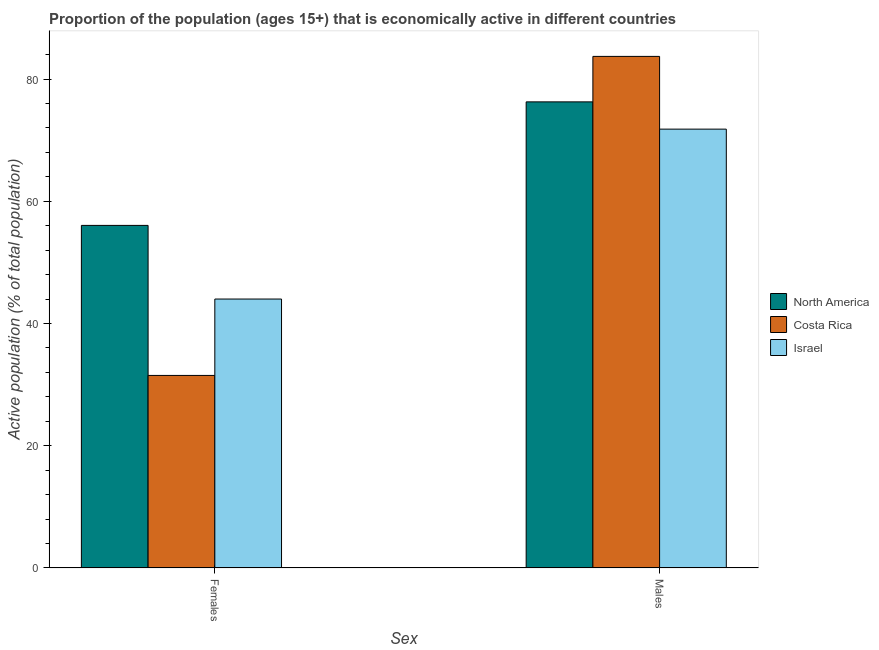How many different coloured bars are there?
Give a very brief answer. 3. Are the number of bars per tick equal to the number of legend labels?
Provide a short and direct response. Yes. How many bars are there on the 2nd tick from the left?
Keep it short and to the point. 3. How many bars are there on the 1st tick from the right?
Provide a succinct answer. 3. What is the label of the 1st group of bars from the left?
Your response must be concise. Females. What is the percentage of economically active female population in North America?
Provide a succinct answer. 56.05. Across all countries, what is the maximum percentage of economically active female population?
Your answer should be compact. 56.05. Across all countries, what is the minimum percentage of economically active female population?
Offer a terse response. 31.5. In which country was the percentage of economically active male population maximum?
Ensure brevity in your answer.  Costa Rica. In which country was the percentage of economically active male population minimum?
Provide a succinct answer. Israel. What is the total percentage of economically active female population in the graph?
Give a very brief answer. 131.55. What is the difference between the percentage of economically active male population in Israel and that in North America?
Offer a terse response. -4.46. What is the difference between the percentage of economically active female population in Costa Rica and the percentage of economically active male population in Israel?
Keep it short and to the point. -40.3. What is the average percentage of economically active male population per country?
Ensure brevity in your answer.  77.25. What is the difference between the percentage of economically active female population and percentage of economically active male population in North America?
Give a very brief answer. -20.21. In how many countries, is the percentage of economically active female population greater than 36 %?
Ensure brevity in your answer.  2. What is the ratio of the percentage of economically active female population in Israel to that in North America?
Provide a short and direct response. 0.79. In how many countries, is the percentage of economically active male population greater than the average percentage of economically active male population taken over all countries?
Provide a succinct answer. 1. What does the 1st bar from the left in Males represents?
Your response must be concise. North America. What does the 2nd bar from the right in Females represents?
Your response must be concise. Costa Rica. How many countries are there in the graph?
Keep it short and to the point. 3. Are the values on the major ticks of Y-axis written in scientific E-notation?
Make the answer very short. No. Does the graph contain any zero values?
Your response must be concise. No. How are the legend labels stacked?
Your response must be concise. Vertical. What is the title of the graph?
Offer a terse response. Proportion of the population (ages 15+) that is economically active in different countries. Does "Somalia" appear as one of the legend labels in the graph?
Provide a short and direct response. No. What is the label or title of the X-axis?
Give a very brief answer. Sex. What is the label or title of the Y-axis?
Offer a very short reply. Active population (% of total population). What is the Active population (% of total population) in North America in Females?
Provide a short and direct response. 56.05. What is the Active population (% of total population) in Costa Rica in Females?
Keep it short and to the point. 31.5. What is the Active population (% of total population) of Israel in Females?
Your response must be concise. 44. What is the Active population (% of total population) in North America in Males?
Your answer should be very brief. 76.26. What is the Active population (% of total population) of Costa Rica in Males?
Offer a terse response. 83.7. What is the Active population (% of total population) of Israel in Males?
Offer a terse response. 71.8. Across all Sex, what is the maximum Active population (% of total population) in North America?
Your answer should be compact. 76.26. Across all Sex, what is the maximum Active population (% of total population) in Costa Rica?
Your answer should be compact. 83.7. Across all Sex, what is the maximum Active population (% of total population) in Israel?
Make the answer very short. 71.8. Across all Sex, what is the minimum Active population (% of total population) in North America?
Ensure brevity in your answer.  56.05. Across all Sex, what is the minimum Active population (% of total population) of Costa Rica?
Provide a succinct answer. 31.5. Across all Sex, what is the minimum Active population (% of total population) in Israel?
Offer a very short reply. 44. What is the total Active population (% of total population) of North America in the graph?
Give a very brief answer. 132.31. What is the total Active population (% of total population) of Costa Rica in the graph?
Offer a terse response. 115.2. What is the total Active population (% of total population) in Israel in the graph?
Your response must be concise. 115.8. What is the difference between the Active population (% of total population) in North America in Females and that in Males?
Provide a short and direct response. -20.21. What is the difference between the Active population (% of total population) of Costa Rica in Females and that in Males?
Offer a very short reply. -52.2. What is the difference between the Active population (% of total population) in Israel in Females and that in Males?
Your answer should be compact. -27.8. What is the difference between the Active population (% of total population) of North America in Females and the Active population (% of total population) of Costa Rica in Males?
Your response must be concise. -27.65. What is the difference between the Active population (% of total population) of North America in Females and the Active population (% of total population) of Israel in Males?
Give a very brief answer. -15.75. What is the difference between the Active population (% of total population) in Costa Rica in Females and the Active population (% of total population) in Israel in Males?
Keep it short and to the point. -40.3. What is the average Active population (% of total population) of North America per Sex?
Your response must be concise. 66.15. What is the average Active population (% of total population) of Costa Rica per Sex?
Offer a very short reply. 57.6. What is the average Active population (% of total population) of Israel per Sex?
Your answer should be very brief. 57.9. What is the difference between the Active population (% of total population) in North America and Active population (% of total population) in Costa Rica in Females?
Give a very brief answer. 24.55. What is the difference between the Active population (% of total population) in North America and Active population (% of total population) in Israel in Females?
Your answer should be compact. 12.05. What is the difference between the Active population (% of total population) in Costa Rica and Active population (% of total population) in Israel in Females?
Ensure brevity in your answer.  -12.5. What is the difference between the Active population (% of total population) in North America and Active population (% of total population) in Costa Rica in Males?
Give a very brief answer. -7.44. What is the difference between the Active population (% of total population) in North America and Active population (% of total population) in Israel in Males?
Give a very brief answer. 4.46. What is the ratio of the Active population (% of total population) in North America in Females to that in Males?
Offer a terse response. 0.73. What is the ratio of the Active population (% of total population) in Costa Rica in Females to that in Males?
Ensure brevity in your answer.  0.38. What is the ratio of the Active population (% of total population) of Israel in Females to that in Males?
Your answer should be compact. 0.61. What is the difference between the highest and the second highest Active population (% of total population) in North America?
Provide a succinct answer. 20.21. What is the difference between the highest and the second highest Active population (% of total population) of Costa Rica?
Your answer should be very brief. 52.2. What is the difference between the highest and the second highest Active population (% of total population) of Israel?
Give a very brief answer. 27.8. What is the difference between the highest and the lowest Active population (% of total population) in North America?
Provide a short and direct response. 20.21. What is the difference between the highest and the lowest Active population (% of total population) in Costa Rica?
Provide a short and direct response. 52.2. What is the difference between the highest and the lowest Active population (% of total population) of Israel?
Provide a succinct answer. 27.8. 